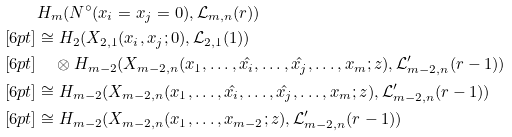Convert formula to latex. <formula><loc_0><loc_0><loc_500><loc_500>& H _ { m } ( N ^ { \circ } ( x _ { i } = x _ { j } = 0 ) , { \mathcal { L } } _ { m , n } ( r ) ) \\ [ 6 p t ] & \cong H _ { 2 } ( X _ { 2 , 1 } ( x _ { i } , x _ { j } ; 0 ) , { \mathcal { L } } _ { 2 , 1 } ( 1 ) ) \\ [ 6 p t ] & \quad \otimes H _ { m - 2 } ( X _ { m - 2 , n } ( x _ { 1 } , \dots , \hat { x _ { i } } , \dots , \hat { x _ { j } } , \dots , x _ { m } ; z ) , { \mathcal { L } } ^ { \prime } _ { m - 2 , n } ( r - 1 ) ) \\ [ 6 p t ] & \cong H _ { m - 2 } ( X _ { m - 2 , n } ( x _ { 1 } , \dots , \hat { x _ { i } } , \dots , \hat { x _ { j } } , \dots , x _ { m } ; z ) , { \mathcal { L } } ^ { \prime } _ { m - 2 , n } ( r - 1 ) ) \\ [ 6 p t ] & \cong H _ { m - 2 } ( X _ { m - 2 , n } ( x _ { 1 } , \dots , x _ { m - 2 } ; z ) , { \mathcal { L } } ^ { \prime } _ { m - 2 , n } ( r - 1 ) )</formula> 